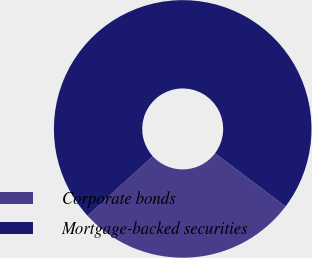<chart> <loc_0><loc_0><loc_500><loc_500><pie_chart><fcel>Corporate bonds<fcel>Mortgage-backed securities<nl><fcel>27.96%<fcel>72.04%<nl></chart> 